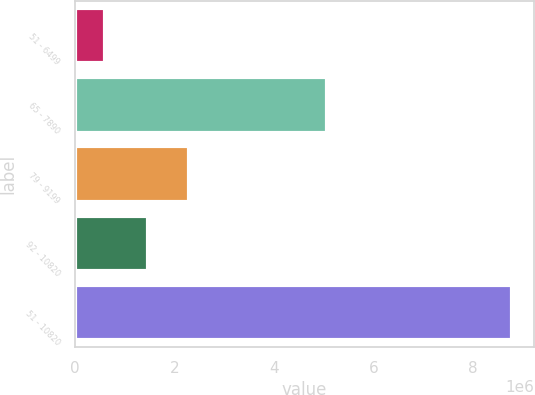Convert chart to OTSL. <chart><loc_0><loc_0><loc_500><loc_500><bar_chart><fcel>51 - 6499<fcel>65 - 7890<fcel>79 - 9199<fcel>92 - 10820<fcel>51 - 10820<nl><fcel>613481<fcel>5.07626e+06<fcel>2.28747e+06<fcel>1.4706e+06<fcel>8.78215e+06<nl></chart> 